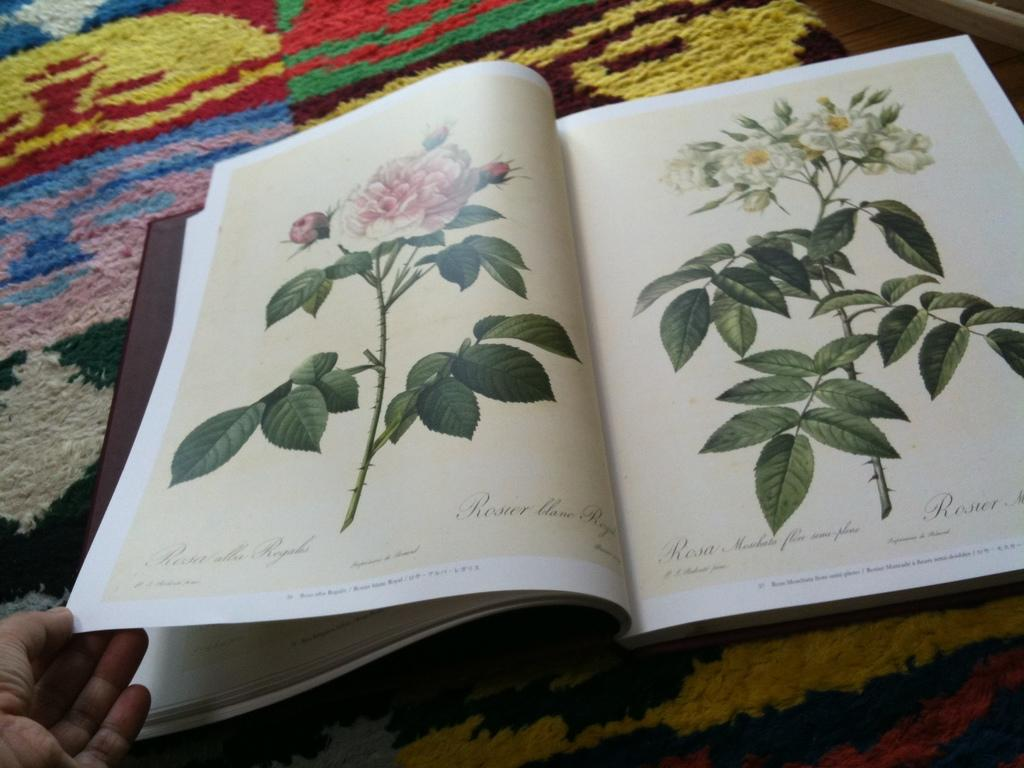Provide a one-sentence caption for the provided image. A book sitting on a rug showing flowers says Rosier on it. 